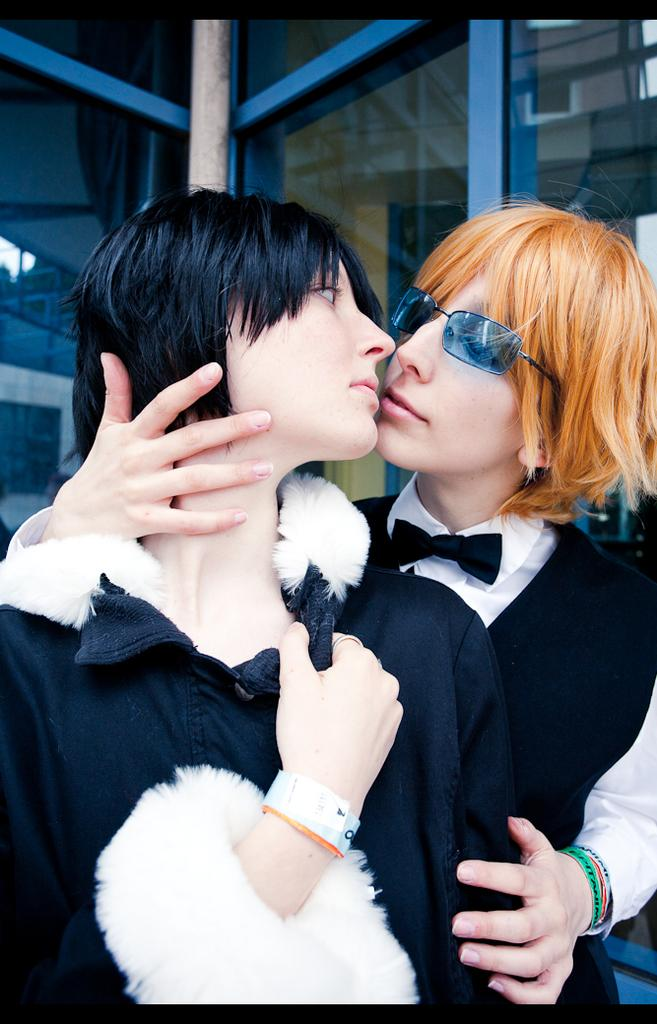How many women are in the image? There are two women in the image. What are the women wearing? The women are wearing white and black dresses. Can you describe any accessories the women are wearing? One of the women is wearing shades. What can be seen in the background of the image? There is a window with glass visible in the background of the image. What type of smoke can be seen coming from the gun in the image? There is no smoke or gun present in the image; it features two women wearing dresses and shades. 